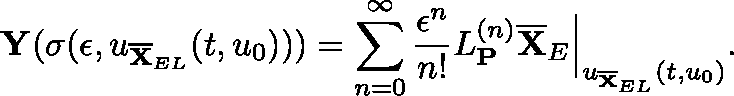Convert formula to latex. <formula><loc_0><loc_0><loc_500><loc_500>Y ( \sigma ( \epsilon , \mathfrak { u } _ { \overline { X } _ { E L } } ( t , \mathfrak { u } _ { 0 } ) ) ) = \sum _ { n = 0 } ^ { \infty } \frac { \epsilon ^ { n } } { n ! } \mathfrak { L } _ { P } ^ { ( n ) } \overline { X } _ { E } \Big | _ { \mathfrak { u } _ { \overline { X } _ { E L } } ( t , \mathfrak { u } _ { 0 } ) } .</formula> 